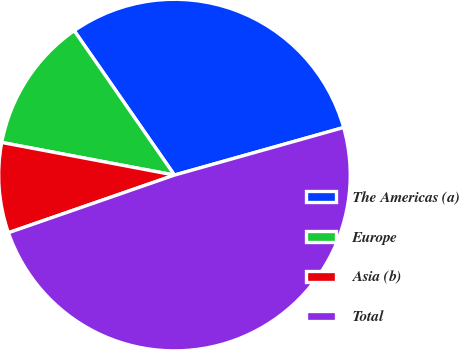<chart> <loc_0><loc_0><loc_500><loc_500><pie_chart><fcel>The Americas (a)<fcel>Europe<fcel>Asia (b)<fcel>Total<nl><fcel>30.29%<fcel>12.37%<fcel>8.29%<fcel>49.04%<nl></chart> 